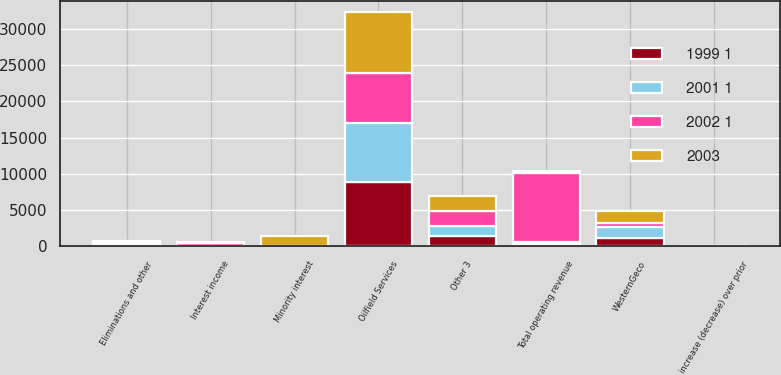<chart> <loc_0><loc_0><loc_500><loc_500><stacked_bar_chart><ecel><fcel>Oilfield Services<fcel>WesternGeco<fcel>Other 3<fcel>Eliminations and other<fcel>Total operating revenue<fcel>increase (decrease) over prior<fcel>Minority interest<fcel>Interest income<nl><fcel>1999 1<fcel>8823<fcel>1183<fcel>1480<fcel>270<fcel>297<fcel>6<fcel>10<fcel>49<nl><fcel>2001 1<fcel>8171<fcel>1476<fcel>1334<fcel>272<fcel>297<fcel>5<fcel>1<fcel>68<nl><fcel>2003<fcel>8381<fcel>1702<fcel>2016<fcel>176<fcel>297<fcel>45<fcel>1419<fcel>153<nl><fcel>2002 1<fcel>6855<fcel>511<fcel>2095<fcel>73<fcel>9458<fcel>15<fcel>7<fcel>297<nl></chart> 